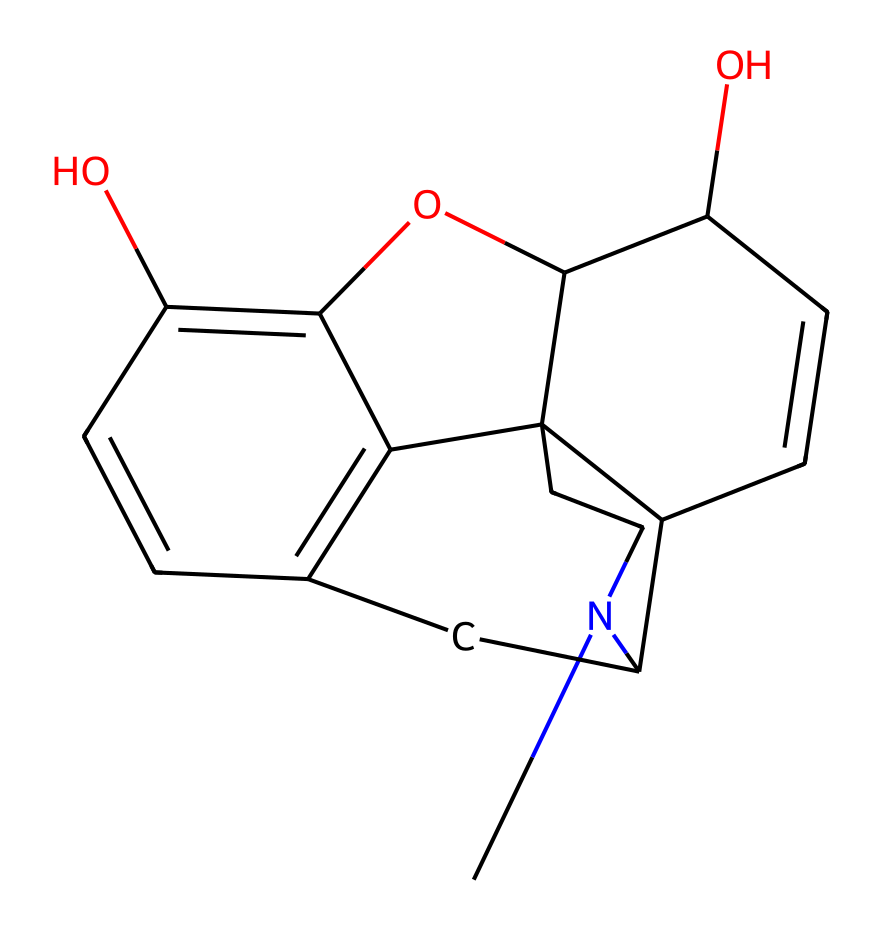What is the IUPAC name of the compound represented by this SMILES? The SMILES representation corresponds to morphine, which has a well-established IUPAC name. Upon analyzing the structure, we identify functional groups and ring systems typical to morphine.
Answer: morphine How many carbon atoms are present in the structure? By examining the SMILES, we can count the 'C' symbols representing carbon atoms. Each carbon is included in the count for a total of 17 carbon atoms in the structure.
Answer: 17 What type of functional groups are found in morphine? The structure contains hydroxyl groups (-OH) and a tertiary amine group, which are characteristic of morphine. Identifying these functionalities is crucial in understanding the compound's properties.
Answer: hydroxyl and amine What is the number of rings present in the morphine structure? Analyzing the structure shows that it contains five carbon rings. They can be identified by tracing the cyclic structures indicated in the SMILES.
Answer: 5 Which atom is responsible for morphine's potential psychoactive effects? The nitrogen atom in the structure is indicative of the alkaloid class, which is mostly associated with psychoactive properties. This nitrogen plays a key role in binding to certain receptors in the brain.
Answer: nitrogen What pharmacological action is primarily associated with morphine? Morphine is primarily known for its analgesic properties, which refer to its ability to relieve pain effectively. This pharmacological action can be inferred from its structural characteristics and known medical uses.
Answer: analgesic What is the primary research application of morphine in pain management? Morphine is primarily studied for its effectiveness in treating acute pain and chronic pain conditions. Its significant value in pain management research is due to its pharmacodynamics and pharmacokinetics.
Answer: pain management 